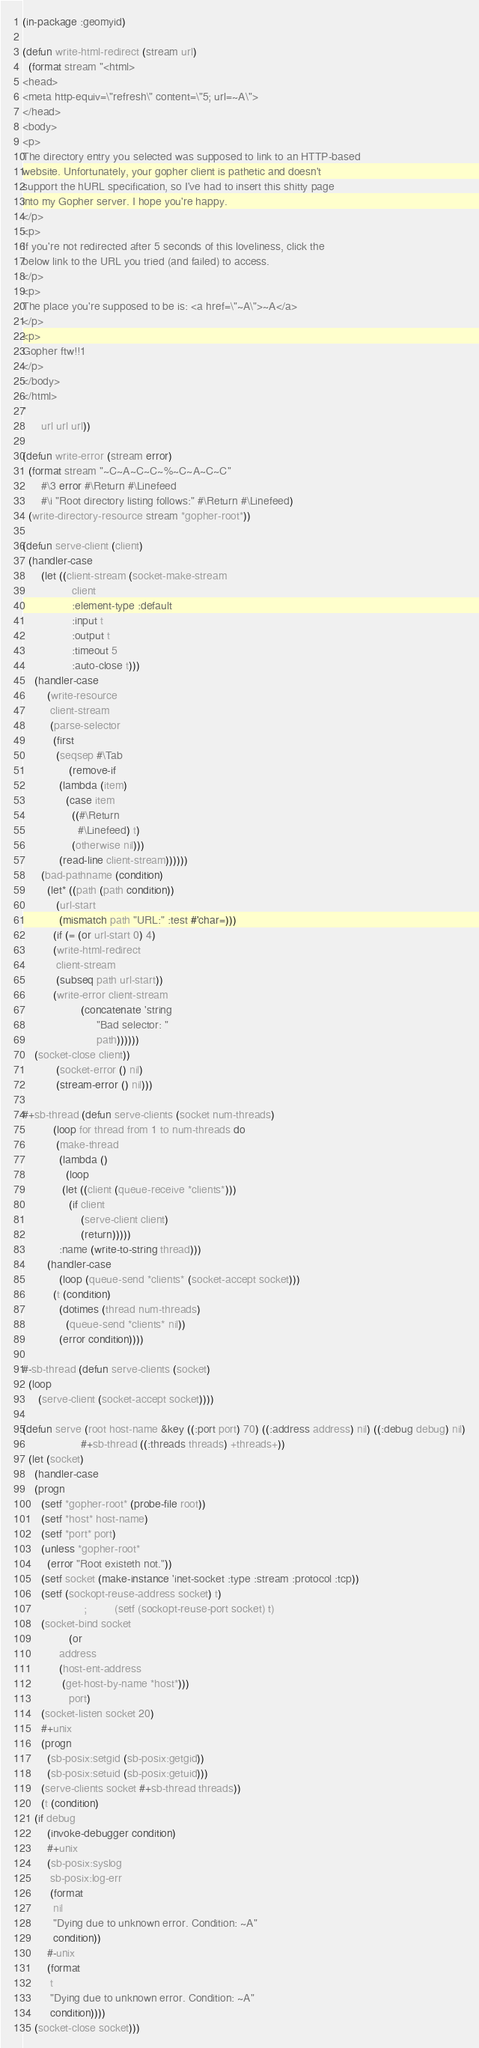Convert code to text. <code><loc_0><loc_0><loc_500><loc_500><_Lisp_>(in-package :geomyid)

(defun write-html-redirect (stream url)
  (format stream "<html>
<head>
<meta http-equiv=\"refresh\" content=\"5; url=~A\">
</head>
<body>
<p>
The directory entry you selected was supposed to link to an HTTP-based
website. Unfortunately, your gopher client is pathetic and doesn't
support the hURL specification, so I've had to insert this shitty page
into my Gopher server. I hope you're happy.
</p>
<p>
If you're not redirected after 5 seconds of this loveliness, click the
below link to the URL you tried (and failed) to access.
</p>
<p>
The place you're supposed to be is: <a href=\"~A\">~A</a>
</p>
<p>
Gopher ftw!!1
</p>
</body>
</html>
"
	  url url url))

(defun write-error (stream error)
  (format stream "~C~A~C~C~%~C~A~C~C"
	  #\3 error #\Return #\Linefeed
	  #\i "Root directory listing follows:" #\Return #\Linefeed)
  (write-directory-resource stream *gopher-root*))

(defun serve-client (client)
  (handler-case
      (let ((client-stream (socket-make-stream
			    client
			    :element-type :default
			    :input t
			    :output t
			    :timeout 5
			    :auto-close t)))
	(handler-case
	    (write-resource
	     client-stream
	     (parse-selector
	      (first
	       (seqsep #\Tab
		       (remove-if
			(lambda (item)
			  (case item
			    ((#\Return
			      #\Linefeed) t)
			    (otherwise nil)))
			(read-line client-stream))))))
	  (bad-pathname (condition)
	    (let* ((path (path condition))
		   (url-start
		    (mismatch path "URL:" :test #'char=)))
	      (if (= (or url-start 0) 4)
		  (write-html-redirect
		   client-stream
		   (subseq path url-start))
		  (write-error client-stream
			       (concatenate 'string
					    "Bad selector: "
					    path))))))
	(socket-close client))
	       (socket-error () nil)
	       (stream-error () nil)))

#+sb-thread (defun serve-clients (socket num-threads)
	      (loop for thread from 1 to num-threads do
		   (make-thread
		    (lambda ()
		      (loop
			 (let ((client (queue-receive *clients*)))
			   (if client
			       (serve-client client)
			       (return)))))
		    :name (write-to-string thread)))
		(handler-case
		    (loop (queue-send *clients* (socket-accept socket)))
		  (t (condition)
		    (dotimes (thread num-threads)
		      (queue-send *clients* nil))
		    (error condition))))

#-sb-thread (defun serve-clients (socket)
  (loop
     (serve-client (socket-accept socket))))

(defun serve (root host-name &key ((:port port) 70) ((:address address) nil) ((:debug debug) nil)
			       #+sb-thread ((:threads threads) +threads+))
  (let (socket)
    (handler-case
	(progn
	  (setf *gopher-root* (probe-file root))
	  (setf *host* host-name)
	  (setf *port* port)
	  (unless *gopher-root*
	    (error "Root existeth not."))
	  (setf socket (make-instance 'inet-socket :type :stream :protocol :tcp))
	  (setf (sockopt-reuse-address socket) t)
					;         (setf (sockopt-reuse-port socket) t)
	  (socket-bind socket
		       (or
			address
			(host-ent-address
			 (get-host-by-name *host*)))
		       port)
	  (socket-listen socket 20)
	  #+unix
	  (progn
	    (sb-posix:setgid (sb-posix:getgid))
	    (sb-posix:setuid (sb-posix:getuid)))
	  (serve-clients socket #+sb-thread threads))
      (t (condition)
	(if debug
	    (invoke-debugger condition)
	    #+unix
	    (sb-posix:syslog
	     sb-posix:log-err
	     (format
	      nil
	      "Dying due to unknown error. Condition: ~A"
	      condition))
	    #-unix
	    (format
	     t
	     "Dying due to unknown error. Condition: ~A"
	     condition))))
    (socket-close socket)))
</code> 